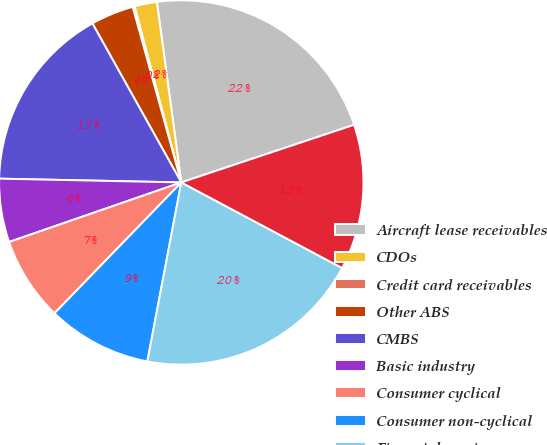Convert chart. <chart><loc_0><loc_0><loc_500><loc_500><pie_chart><fcel>Aircraft lease receivables<fcel>CDOs<fcel>Credit card receivables<fcel>Other ABS<fcel>CMBS<fcel>Basic industry<fcel>Consumer cyclical<fcel>Consumer non-cyclical<fcel>Financial services<fcel>Technology and communications<nl><fcel>22.02%<fcel>1.99%<fcel>0.17%<fcel>3.81%<fcel>16.56%<fcel>5.63%<fcel>7.45%<fcel>9.27%<fcel>20.2%<fcel>12.91%<nl></chart> 